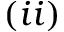Convert formula to latex. <formula><loc_0><loc_0><loc_500><loc_500>( i i )</formula> 